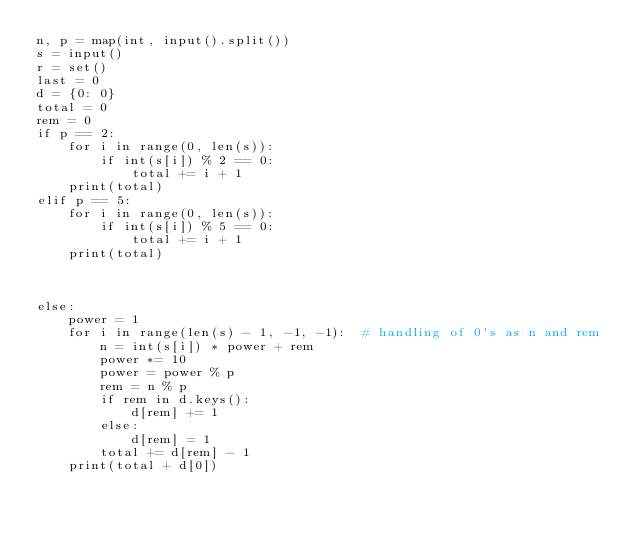Convert code to text. <code><loc_0><loc_0><loc_500><loc_500><_Python_>n, p = map(int, input().split())
s = input()
r = set()
last = 0
d = {0: 0}
total = 0
rem = 0
if p == 2:
    for i in range(0, len(s)):
        if int(s[i]) % 2 == 0:
            total += i + 1
    print(total)
elif p == 5:
    for i in range(0, len(s)):
        if int(s[i]) % 5 == 0:
            total += i + 1
    print(total)



else:
    power = 1
    for i in range(len(s) - 1, -1, -1):  # handling of 0's as n and rem
        n = int(s[i]) * power + rem
        power *= 10
        power = power % p
        rem = n % p
        if rem in d.keys():
            d[rem] += 1
        else:
            d[rem] = 1
        total += d[rem] - 1
    print(total + d[0])</code> 